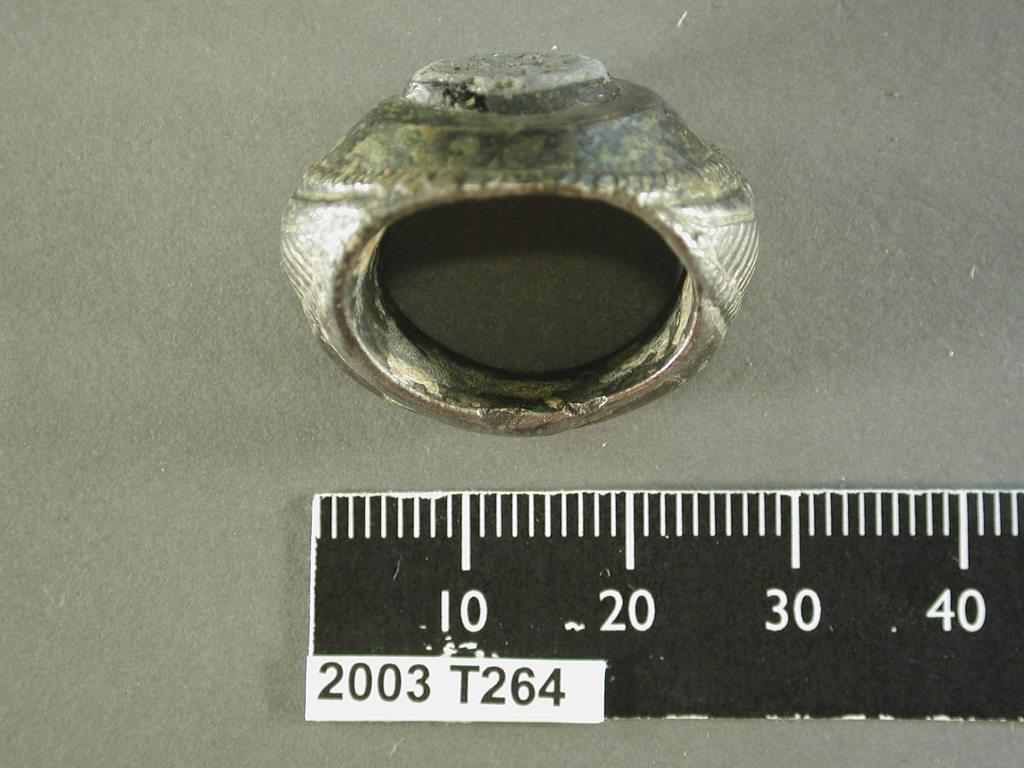<image>
Render a clear and concise summary of the photo. An old rings is placed above a ruler labeled 2003 T264. 